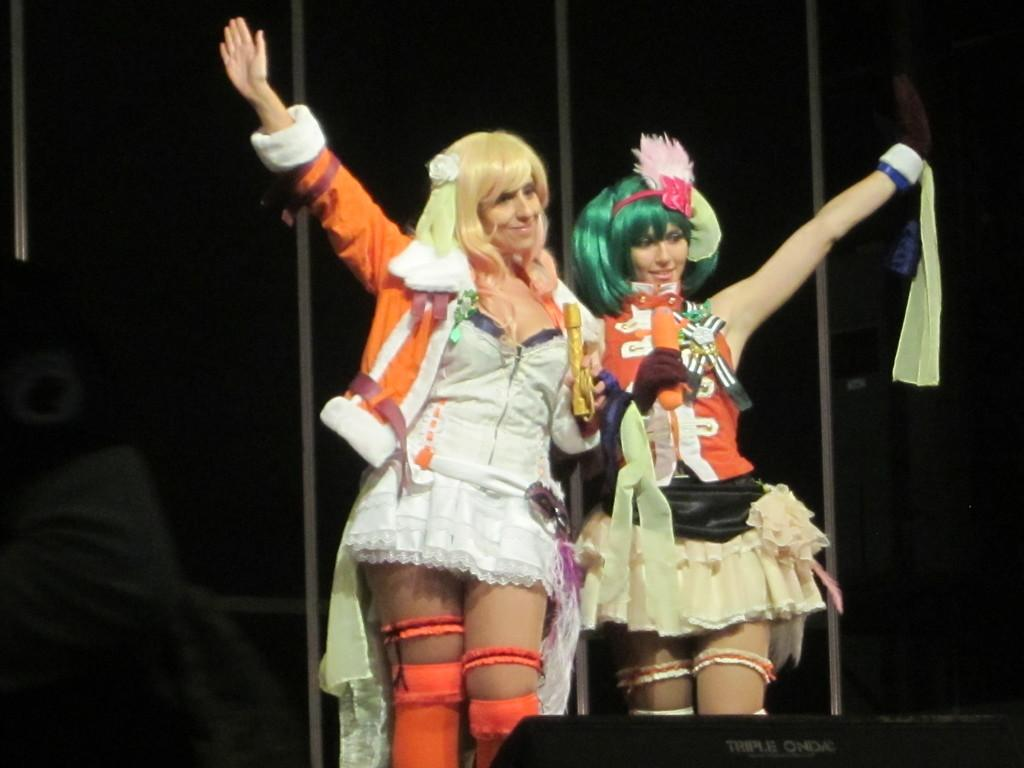How many people are in the image? There are two persons in the image. What are the persons wearing? The persons are wearing costumes. Can you describe the background of the image? The background of the image is dark. What type of glove can be seen on the person's hand in the image? There is no glove visible on the person's hand in the image. What type of gate is present in the image? There is no gate present in the image. 